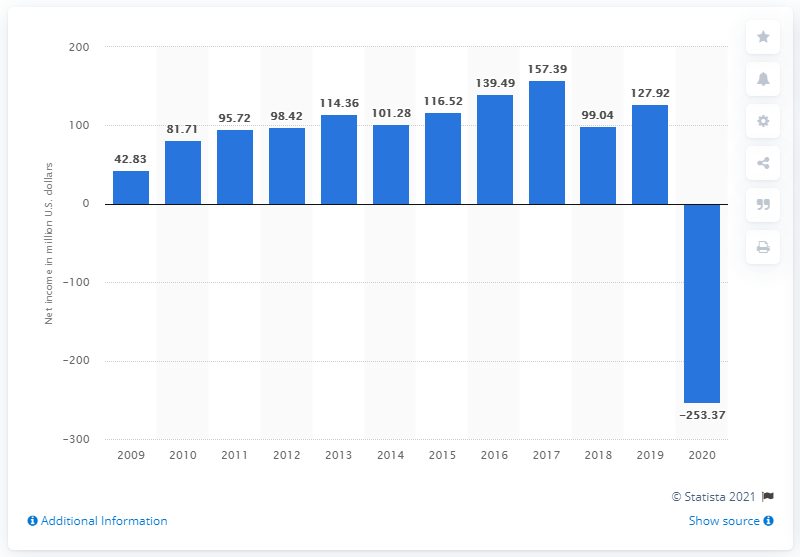Indicate a few pertinent items in this graphic. In 2017, The Cheesecake Factory's net income was 157.39 million dollars. 